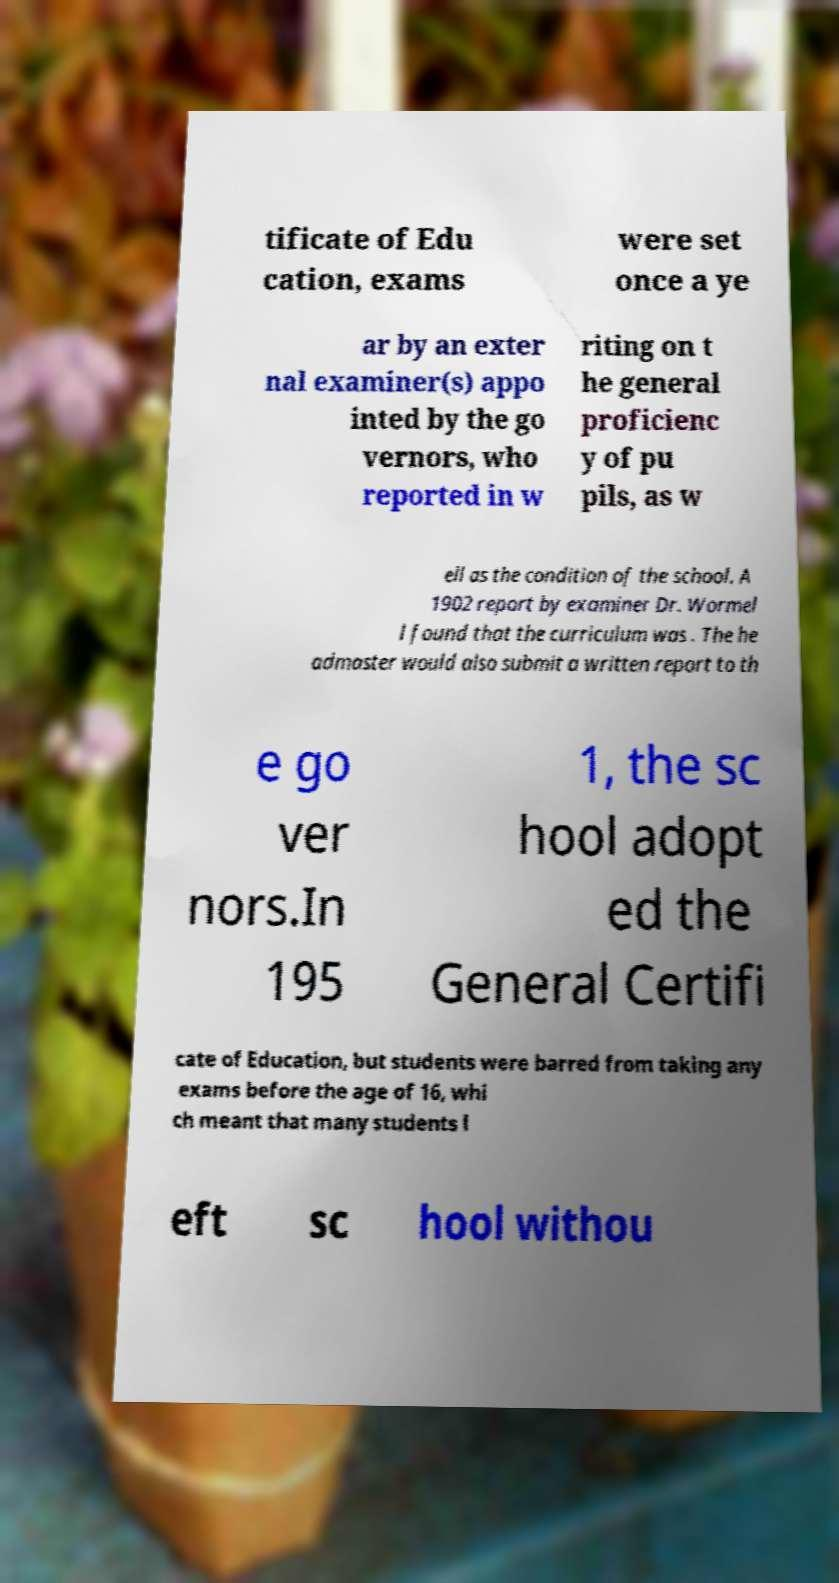For documentation purposes, I need the text within this image transcribed. Could you provide that? tificate of Edu cation, exams were set once a ye ar by an exter nal examiner(s) appo inted by the go vernors, who reported in w riting on t he general proficienc y of pu pils, as w ell as the condition of the school. A 1902 report by examiner Dr. Wormel l found that the curriculum was . The he admaster would also submit a written report to th e go ver nors.In 195 1, the sc hool adopt ed the General Certifi cate of Education, but students were barred from taking any exams before the age of 16, whi ch meant that many students l eft sc hool withou 